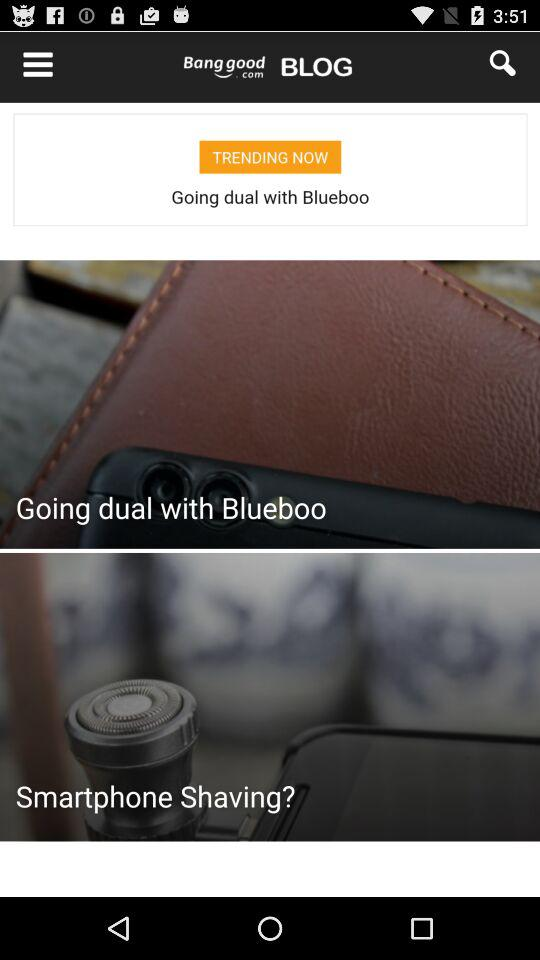What is the count of items in the cart? There is 1 item in the cart. 